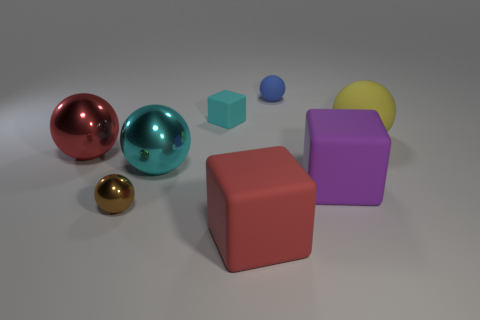Subtract all big red shiny balls. How many balls are left? 4 Add 1 brown metal objects. How many objects exist? 9 Subtract all brown spheres. How many spheres are left? 4 Subtract all blocks. How many objects are left? 5 Subtract 3 blocks. How many blocks are left? 0 Subtract all gray blocks. Subtract all gray cylinders. How many blocks are left? 3 Subtract all yellow cylinders. How many brown spheres are left? 1 Subtract all large rubber spheres. Subtract all cyan matte blocks. How many objects are left? 6 Add 3 large purple rubber objects. How many large purple rubber objects are left? 4 Add 7 big yellow balls. How many big yellow balls exist? 8 